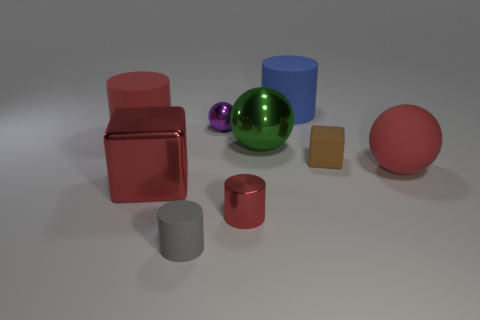Add 1 large red blocks. How many objects exist? 10 Subtract all spheres. How many objects are left? 6 Add 7 purple shiny balls. How many purple shiny balls are left? 8 Add 9 tiny gray rubber things. How many tiny gray rubber things exist? 10 Subtract 0 cyan balls. How many objects are left? 9 Subtract all big red matte cylinders. Subtract all green objects. How many objects are left? 7 